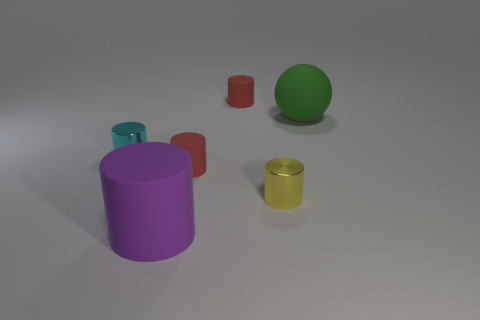Subtract all purple cylinders. How many cylinders are left? 4 Subtract all small cyan shiny cylinders. How many cylinders are left? 4 Subtract all red cylinders. Subtract all green blocks. How many cylinders are left? 3 Add 4 big purple objects. How many objects exist? 10 Subtract all spheres. How many objects are left? 5 Add 3 green objects. How many green objects are left? 4 Add 3 small yellow cylinders. How many small yellow cylinders exist? 4 Subtract 0 gray spheres. How many objects are left? 6 Subtract all purple matte cylinders. Subtract all small shiny cylinders. How many objects are left? 3 